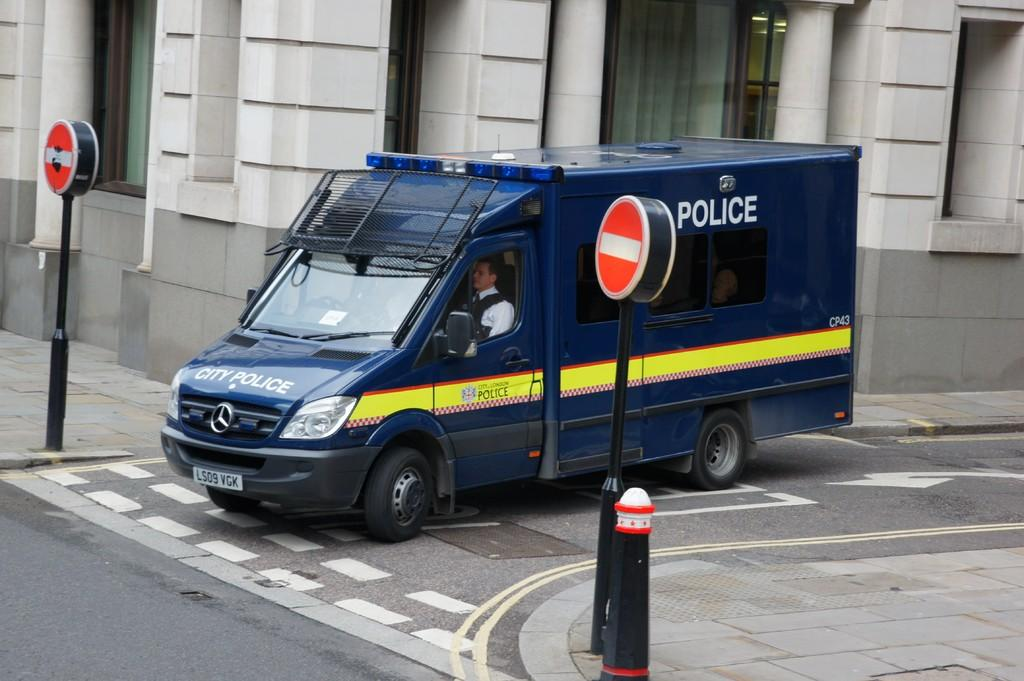<image>
Relay a brief, clear account of the picture shown. a blue Police Van from the City of London 